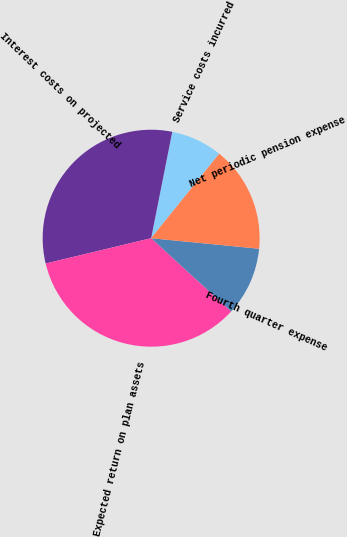<chart> <loc_0><loc_0><loc_500><loc_500><pie_chart><fcel>Service costs incurred<fcel>Interest costs on projected<fcel>Expected return on plan assets<fcel>Fourth quarter expense<fcel>Net periodic pension expense<nl><fcel>7.68%<fcel>31.87%<fcel>34.45%<fcel>10.25%<fcel>15.75%<nl></chart> 